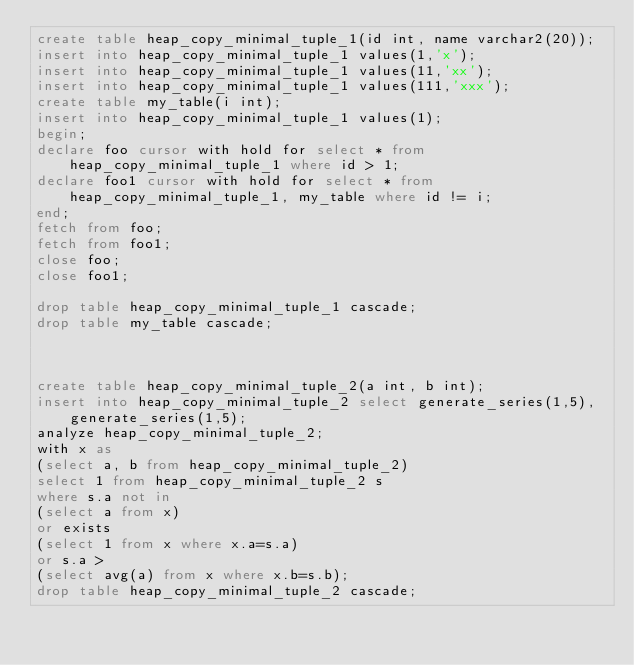Convert code to text. <code><loc_0><loc_0><loc_500><loc_500><_SQL_>create table heap_copy_minimal_tuple_1(id int, name varchar2(20));
insert into heap_copy_minimal_tuple_1 values(1,'x');
insert into heap_copy_minimal_tuple_1 values(11,'xx');
insert into heap_copy_minimal_tuple_1 values(111,'xxx');
create table my_table(i int);
insert into heap_copy_minimal_tuple_1 values(1);
begin;
declare foo cursor with hold for select * from heap_copy_minimal_tuple_1 where id > 1;
declare foo1 cursor with hold for select * from heap_copy_minimal_tuple_1, my_table where id != i;
end;
fetch from foo;
fetch from foo1;
close foo;
close foo1;

drop table heap_copy_minimal_tuple_1 cascade;
drop table my_table cascade;



create table heap_copy_minimal_tuple_2(a int, b int);
insert into heap_copy_minimal_tuple_2 select generate_series(1,5), generate_series(1,5);
analyze heap_copy_minimal_tuple_2;
with x as
(select a, b from heap_copy_minimal_tuple_2)
select 1 from heap_copy_minimal_tuple_2 s 
where s.a not in 
(select a from x)
or exists
(select 1 from x where x.a=s.a)
or s.a >     
(select avg(a) from x where x.b=s.b);
drop table heap_copy_minimal_tuple_2 cascade;</code> 